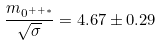Convert formula to latex. <formula><loc_0><loc_0><loc_500><loc_500>\frac { m _ { 0 ^ { + + * } } } { \sqrt { \sigma } } = 4 . 6 7 \pm 0 . 2 9</formula> 